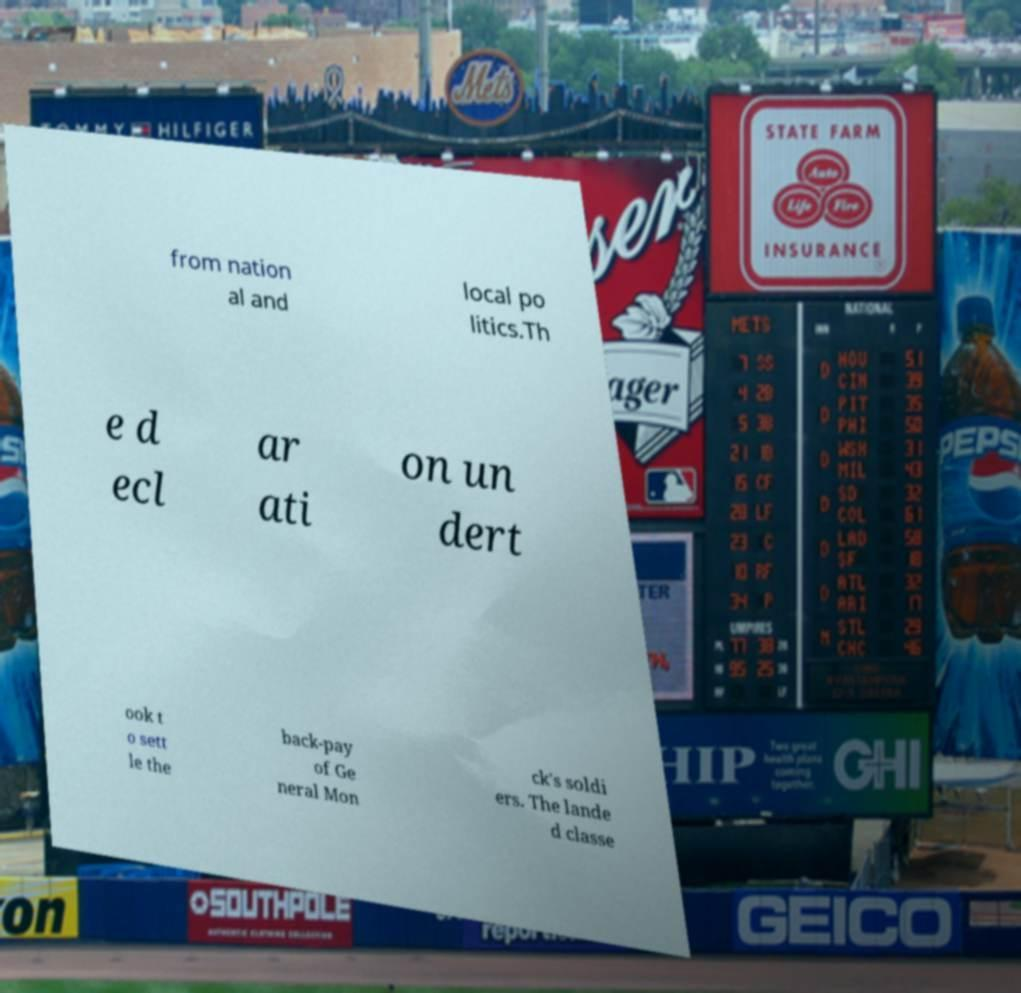Can you read and provide the text displayed in the image?This photo seems to have some interesting text. Can you extract and type it out for me? from nation al and local po litics.Th e d ecl ar ati on un dert ook t o sett le the back-pay of Ge neral Mon ck's soldi ers. The lande d classe 